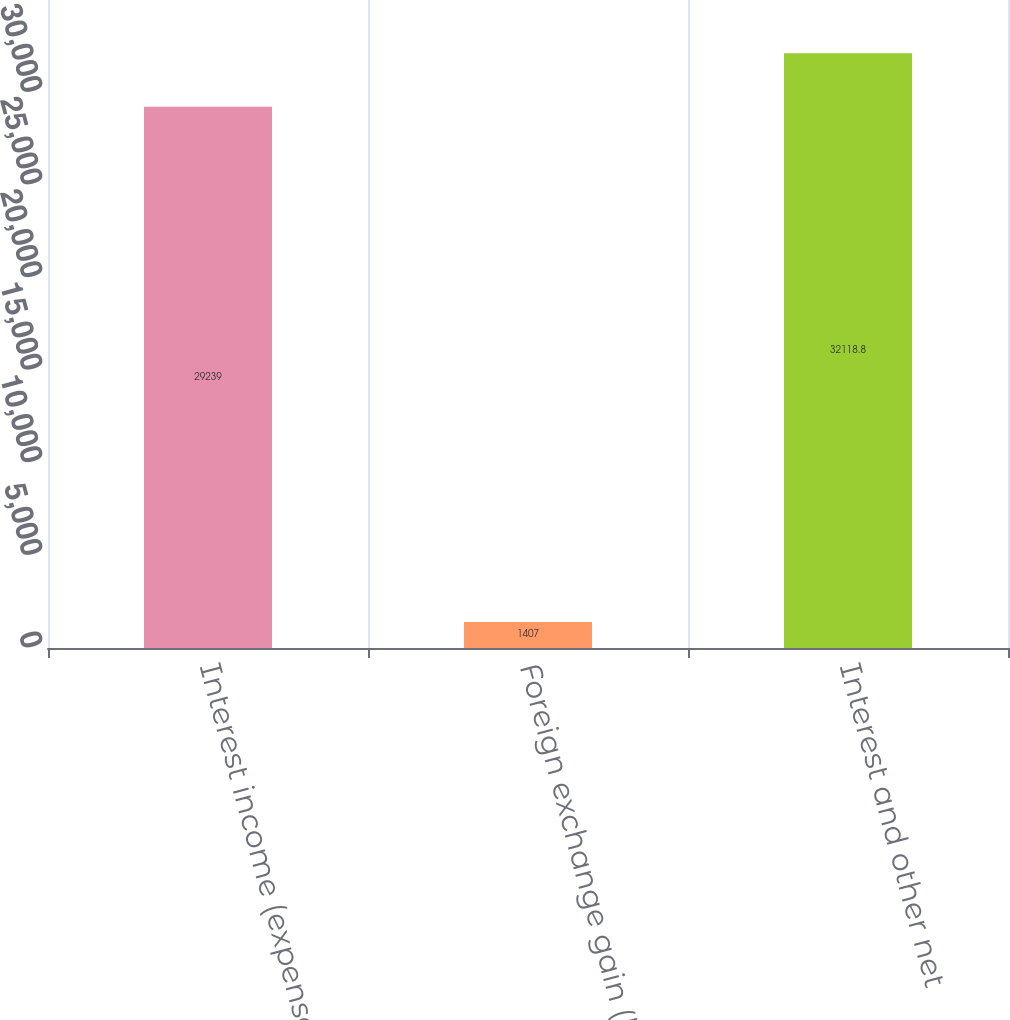Convert chart. <chart><loc_0><loc_0><loc_500><loc_500><bar_chart><fcel>Interest income (expense) net<fcel>Foreign exchange gain (loss)<fcel>Interest and other net<nl><fcel>29239<fcel>1407<fcel>32118.8<nl></chart> 